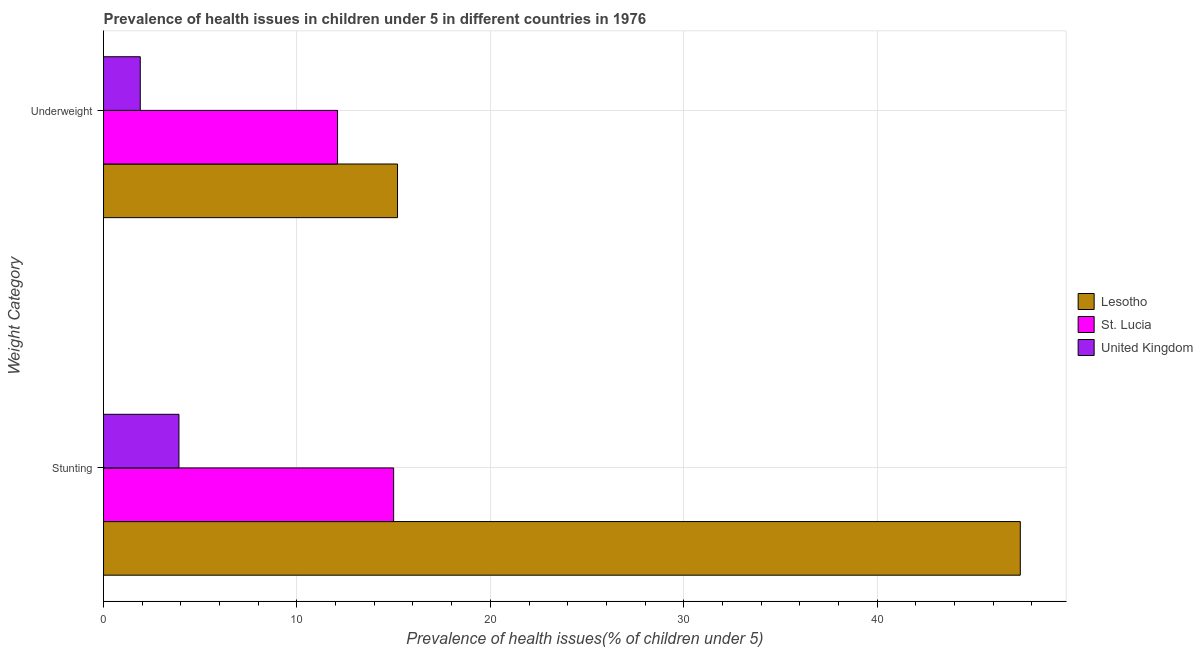How many different coloured bars are there?
Your answer should be compact. 3. Are the number of bars per tick equal to the number of legend labels?
Provide a short and direct response. Yes. Are the number of bars on each tick of the Y-axis equal?
Ensure brevity in your answer.  Yes. How many bars are there on the 2nd tick from the bottom?
Keep it short and to the point. 3. What is the label of the 2nd group of bars from the top?
Your answer should be very brief. Stunting. Across all countries, what is the maximum percentage of underweight children?
Ensure brevity in your answer.  15.2. Across all countries, what is the minimum percentage of stunted children?
Provide a succinct answer. 3.9. In which country was the percentage of stunted children maximum?
Provide a short and direct response. Lesotho. What is the total percentage of stunted children in the graph?
Your answer should be very brief. 66.3. What is the difference between the percentage of stunted children in St. Lucia and that in United Kingdom?
Offer a very short reply. 11.1. What is the difference between the percentage of underweight children in United Kingdom and the percentage of stunted children in Lesotho?
Provide a short and direct response. -45.5. What is the average percentage of underweight children per country?
Your answer should be compact. 9.73. What is the difference between the percentage of underweight children and percentage of stunted children in St. Lucia?
Provide a short and direct response. -2.9. In how many countries, is the percentage of underweight children greater than 30 %?
Keep it short and to the point. 0. What is the ratio of the percentage of underweight children in St. Lucia to that in United Kingdom?
Provide a short and direct response. 6.37. Is the percentage of underweight children in United Kingdom less than that in St. Lucia?
Your response must be concise. Yes. In how many countries, is the percentage of underweight children greater than the average percentage of underweight children taken over all countries?
Provide a succinct answer. 2. What does the 3rd bar from the top in Stunting represents?
Make the answer very short. Lesotho. What does the 1st bar from the bottom in Underweight represents?
Provide a succinct answer. Lesotho. How many bars are there?
Ensure brevity in your answer.  6. Are all the bars in the graph horizontal?
Provide a short and direct response. Yes. Does the graph contain grids?
Provide a short and direct response. Yes. Where does the legend appear in the graph?
Provide a succinct answer. Center right. What is the title of the graph?
Provide a short and direct response. Prevalence of health issues in children under 5 in different countries in 1976. What is the label or title of the X-axis?
Ensure brevity in your answer.  Prevalence of health issues(% of children under 5). What is the label or title of the Y-axis?
Offer a terse response. Weight Category. What is the Prevalence of health issues(% of children under 5) in Lesotho in Stunting?
Your response must be concise. 47.4. What is the Prevalence of health issues(% of children under 5) of St. Lucia in Stunting?
Provide a short and direct response. 15. What is the Prevalence of health issues(% of children under 5) in United Kingdom in Stunting?
Make the answer very short. 3.9. What is the Prevalence of health issues(% of children under 5) in Lesotho in Underweight?
Your answer should be compact. 15.2. What is the Prevalence of health issues(% of children under 5) of St. Lucia in Underweight?
Keep it short and to the point. 12.1. What is the Prevalence of health issues(% of children under 5) of United Kingdom in Underweight?
Keep it short and to the point. 1.9. Across all Weight Category, what is the maximum Prevalence of health issues(% of children under 5) of Lesotho?
Ensure brevity in your answer.  47.4. Across all Weight Category, what is the maximum Prevalence of health issues(% of children under 5) of United Kingdom?
Provide a short and direct response. 3.9. Across all Weight Category, what is the minimum Prevalence of health issues(% of children under 5) of Lesotho?
Provide a succinct answer. 15.2. Across all Weight Category, what is the minimum Prevalence of health issues(% of children under 5) of St. Lucia?
Make the answer very short. 12.1. Across all Weight Category, what is the minimum Prevalence of health issues(% of children under 5) of United Kingdom?
Make the answer very short. 1.9. What is the total Prevalence of health issues(% of children under 5) in Lesotho in the graph?
Your answer should be compact. 62.6. What is the total Prevalence of health issues(% of children under 5) in St. Lucia in the graph?
Offer a terse response. 27.1. What is the total Prevalence of health issues(% of children under 5) in United Kingdom in the graph?
Offer a very short reply. 5.8. What is the difference between the Prevalence of health issues(% of children under 5) in Lesotho in Stunting and that in Underweight?
Keep it short and to the point. 32.2. What is the difference between the Prevalence of health issues(% of children under 5) in St. Lucia in Stunting and that in Underweight?
Offer a terse response. 2.9. What is the difference between the Prevalence of health issues(% of children under 5) in United Kingdom in Stunting and that in Underweight?
Offer a terse response. 2. What is the difference between the Prevalence of health issues(% of children under 5) of Lesotho in Stunting and the Prevalence of health issues(% of children under 5) of St. Lucia in Underweight?
Give a very brief answer. 35.3. What is the difference between the Prevalence of health issues(% of children under 5) in Lesotho in Stunting and the Prevalence of health issues(% of children under 5) in United Kingdom in Underweight?
Provide a short and direct response. 45.5. What is the average Prevalence of health issues(% of children under 5) in Lesotho per Weight Category?
Your answer should be very brief. 31.3. What is the average Prevalence of health issues(% of children under 5) in St. Lucia per Weight Category?
Provide a succinct answer. 13.55. What is the average Prevalence of health issues(% of children under 5) of United Kingdom per Weight Category?
Make the answer very short. 2.9. What is the difference between the Prevalence of health issues(% of children under 5) in Lesotho and Prevalence of health issues(% of children under 5) in St. Lucia in Stunting?
Your response must be concise. 32.4. What is the difference between the Prevalence of health issues(% of children under 5) in Lesotho and Prevalence of health issues(% of children under 5) in United Kingdom in Stunting?
Offer a terse response. 43.5. What is the ratio of the Prevalence of health issues(% of children under 5) of Lesotho in Stunting to that in Underweight?
Ensure brevity in your answer.  3.12. What is the ratio of the Prevalence of health issues(% of children under 5) in St. Lucia in Stunting to that in Underweight?
Your response must be concise. 1.24. What is the ratio of the Prevalence of health issues(% of children under 5) in United Kingdom in Stunting to that in Underweight?
Provide a succinct answer. 2.05. What is the difference between the highest and the second highest Prevalence of health issues(% of children under 5) of Lesotho?
Offer a terse response. 32.2. What is the difference between the highest and the second highest Prevalence of health issues(% of children under 5) in St. Lucia?
Your answer should be very brief. 2.9. What is the difference between the highest and the second highest Prevalence of health issues(% of children under 5) in United Kingdom?
Make the answer very short. 2. What is the difference between the highest and the lowest Prevalence of health issues(% of children under 5) of Lesotho?
Ensure brevity in your answer.  32.2. What is the difference between the highest and the lowest Prevalence of health issues(% of children under 5) of St. Lucia?
Provide a short and direct response. 2.9. What is the difference between the highest and the lowest Prevalence of health issues(% of children under 5) in United Kingdom?
Provide a succinct answer. 2. 